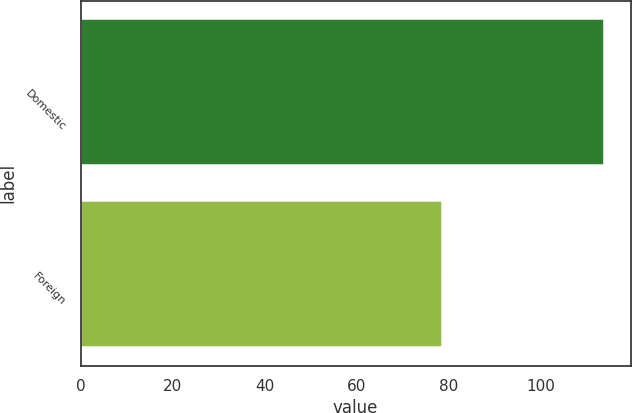Convert chart. <chart><loc_0><loc_0><loc_500><loc_500><bar_chart><fcel>Domestic<fcel>Foreign<nl><fcel>113.9<fcel>78.7<nl></chart> 